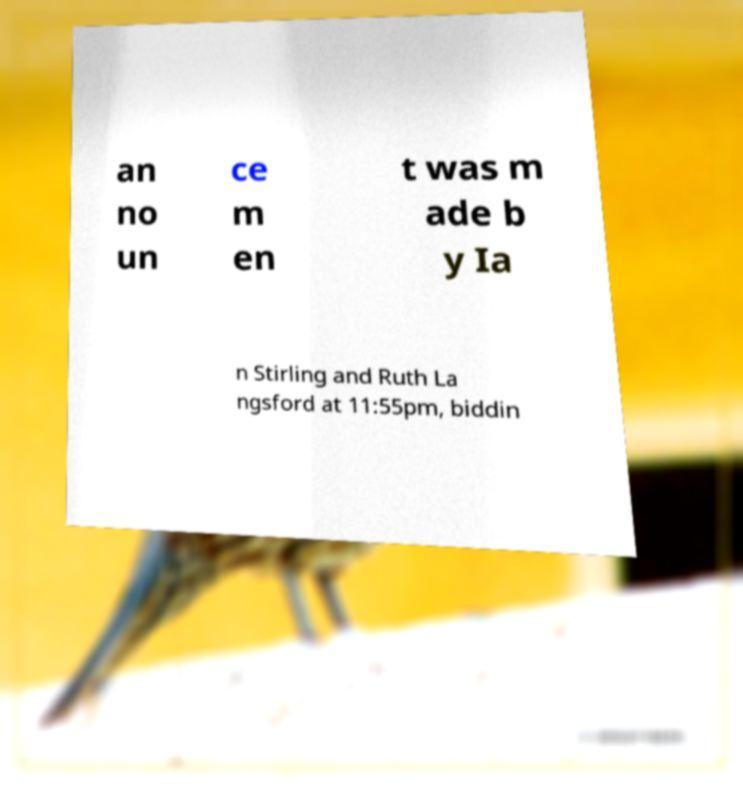Could you extract and type out the text from this image? an no un ce m en t was m ade b y Ia n Stirling and Ruth La ngsford at 11:55pm, biddin 